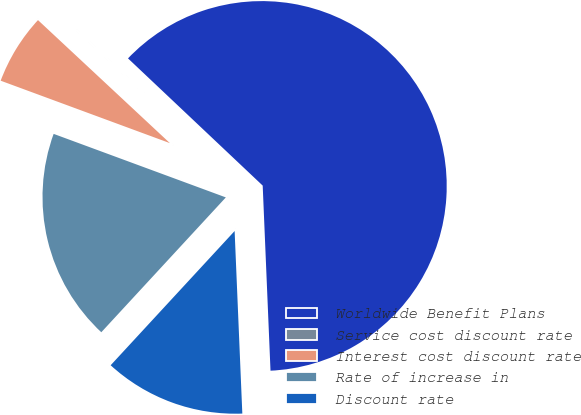Convert chart to OTSL. <chart><loc_0><loc_0><loc_500><loc_500><pie_chart><fcel>Worldwide Benefit Plans<fcel>Service cost discount rate<fcel>Interest cost discount rate<fcel>Rate of increase in<fcel>Discount rate<nl><fcel>62.29%<fcel>0.1%<fcel>6.32%<fcel>18.76%<fcel>12.54%<nl></chart> 